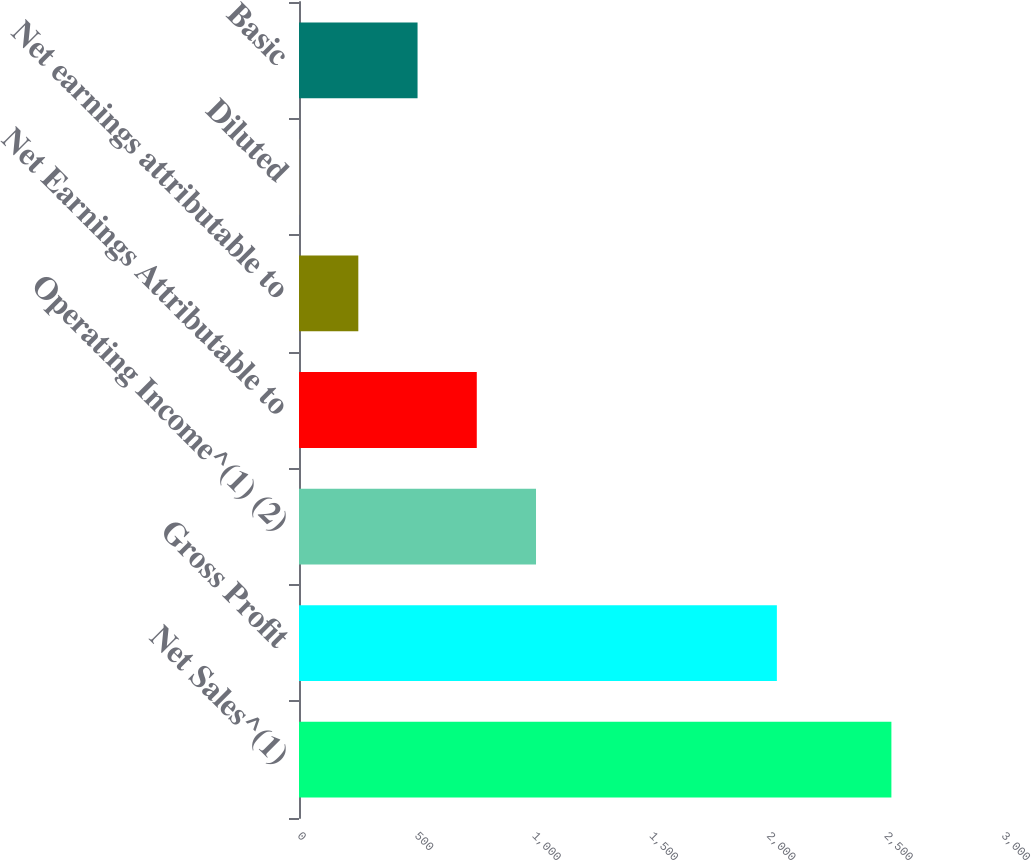<chart> <loc_0><loc_0><loc_500><loc_500><bar_chart><fcel>Net Sales^(1)<fcel>Gross Profit<fcel>Operating Income^(1) (2)<fcel>Net Earnings Attributable to<fcel>Net earnings attributable to<fcel>Diluted<fcel>Basic<nl><fcel>2524.4<fcel>2036.4<fcel>1010<fcel>757.6<fcel>252.8<fcel>0.4<fcel>505.2<nl></chart> 